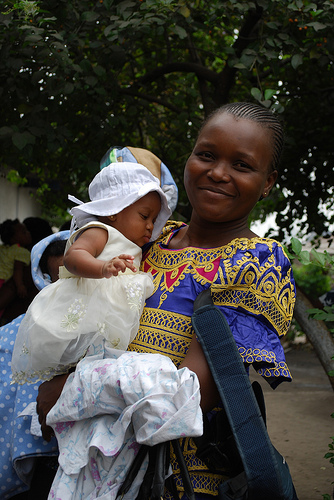<image>
Is the baby under the tree? Yes. The baby is positioned underneath the tree, with the tree above it in the vertical space. Is the baby to the right of the woman? Yes. From this viewpoint, the baby is positioned to the right side relative to the woman. 